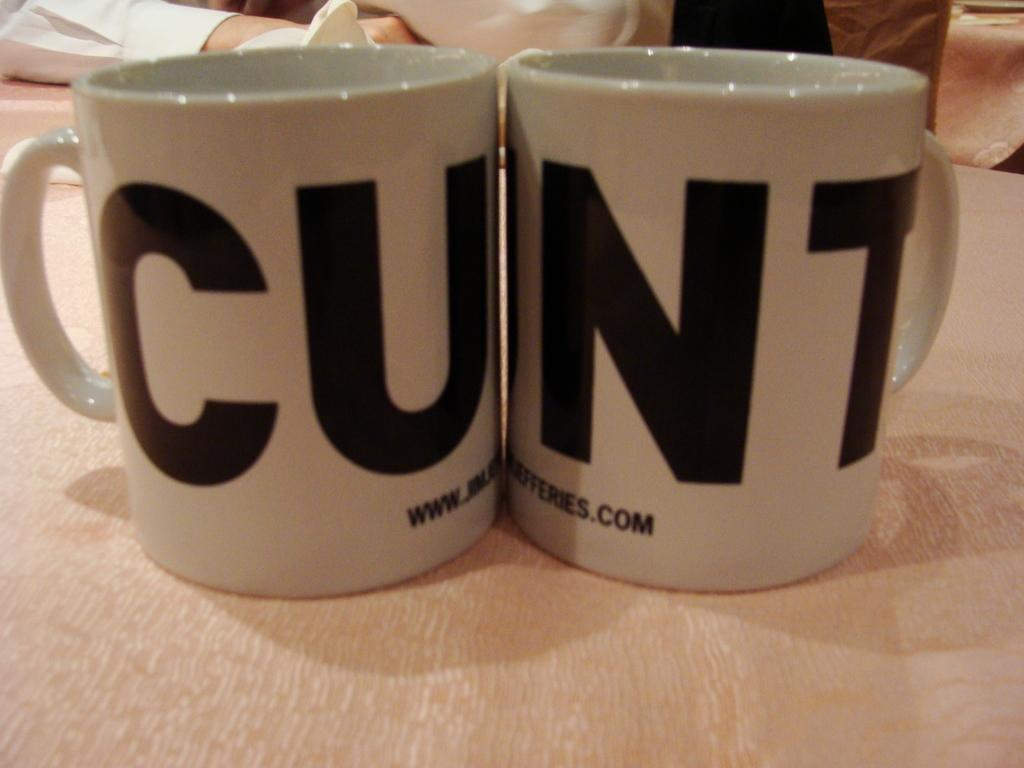<image>
Give a short and clear explanation of the subsequent image. two cups sitting directly next to one another with a word written across them that reads "cunt" 